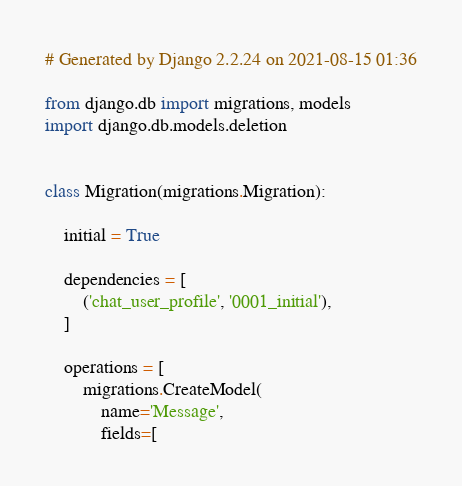Convert code to text. <code><loc_0><loc_0><loc_500><loc_500><_Python_># Generated by Django 2.2.24 on 2021-08-15 01:36

from django.db import migrations, models
import django.db.models.deletion


class Migration(migrations.Migration):

    initial = True

    dependencies = [
        ('chat_user_profile', '0001_initial'),
    ]

    operations = [
        migrations.CreateModel(
            name='Message',
            fields=[</code> 